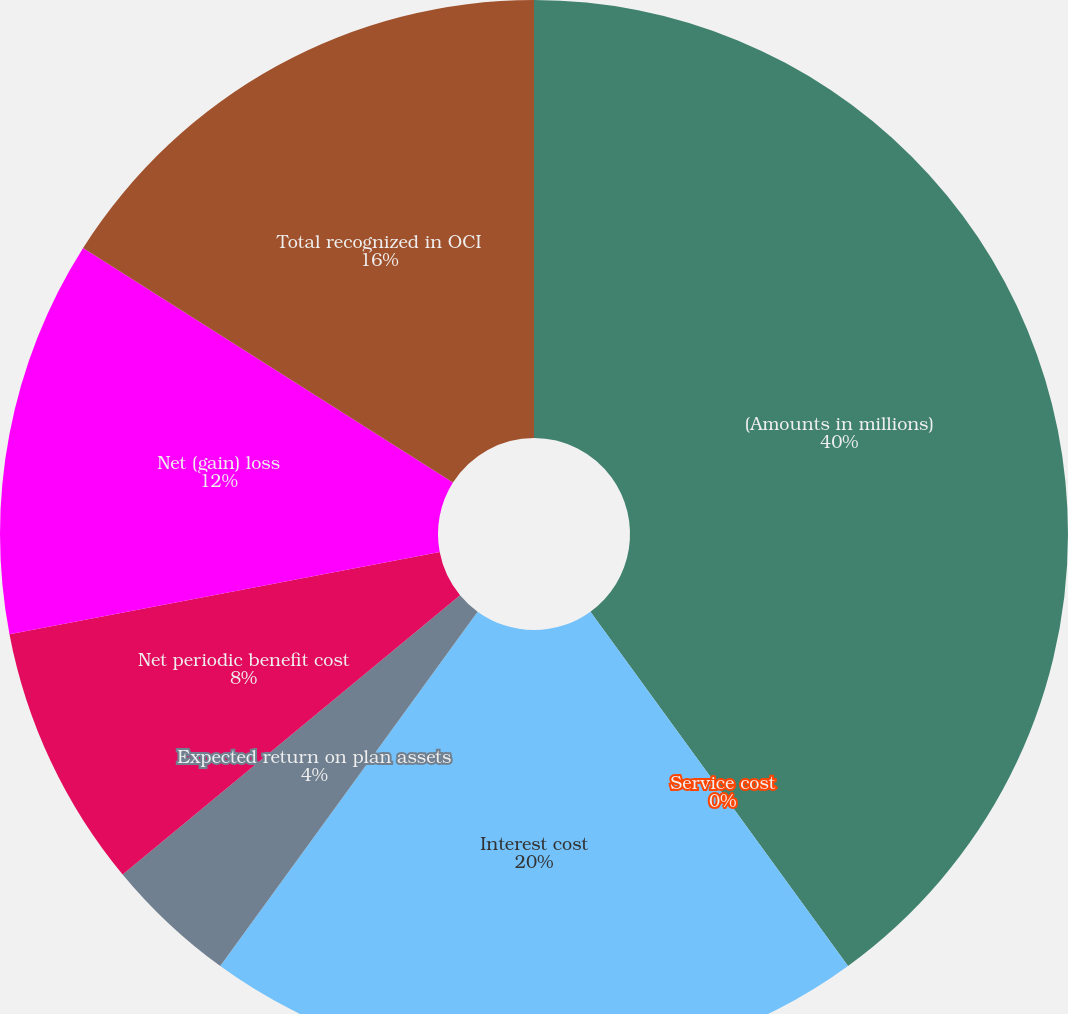Convert chart. <chart><loc_0><loc_0><loc_500><loc_500><pie_chart><fcel>(Amounts in millions)<fcel>Service cost<fcel>Interest cost<fcel>Expected return on plan assets<fcel>Net periodic benefit cost<fcel>Net (gain) loss<fcel>Total recognized in OCI<nl><fcel>39.99%<fcel>0.0%<fcel>20.0%<fcel>4.0%<fcel>8.0%<fcel>12.0%<fcel>16.0%<nl></chart> 